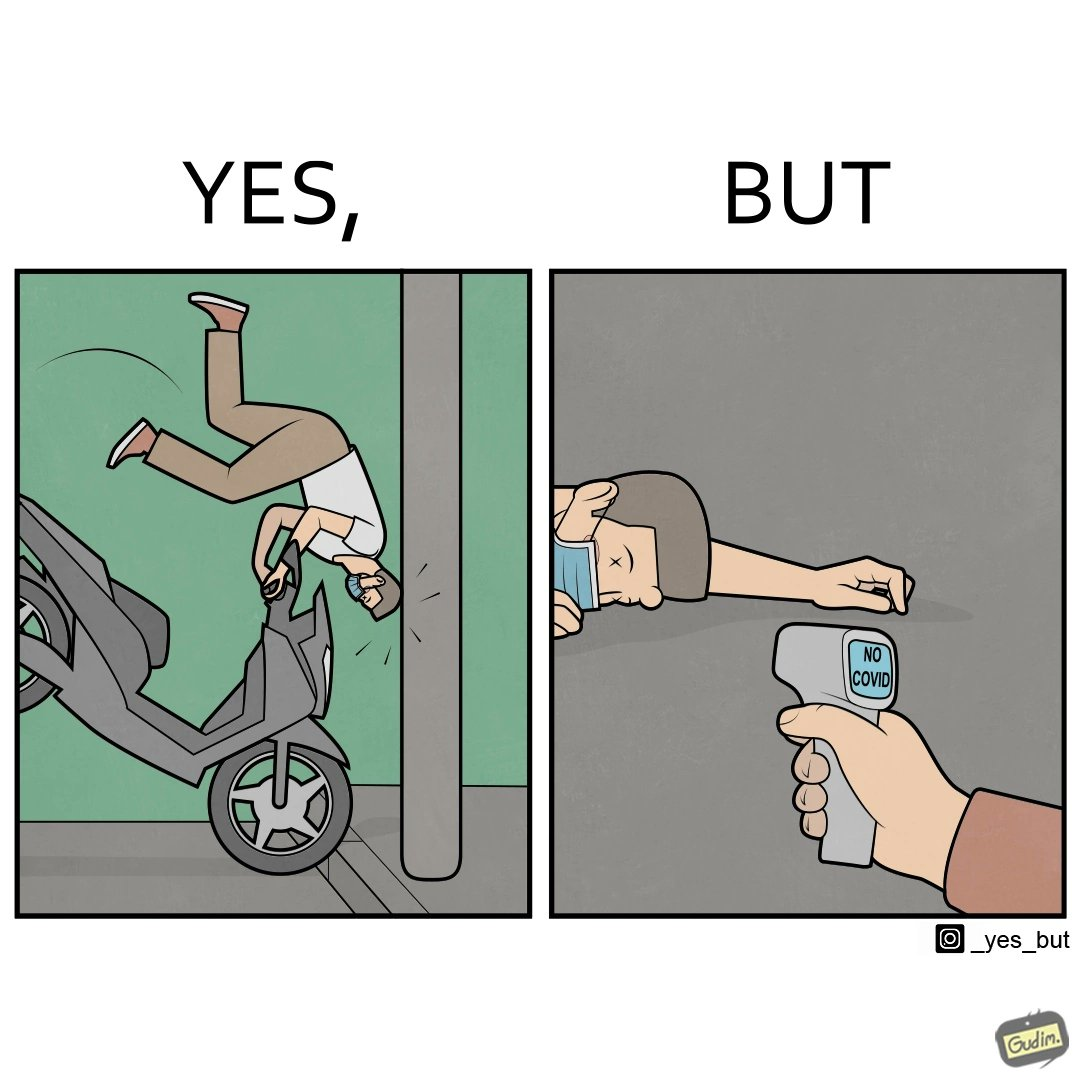Is this a satirical image? Yes, this image is satirical. 